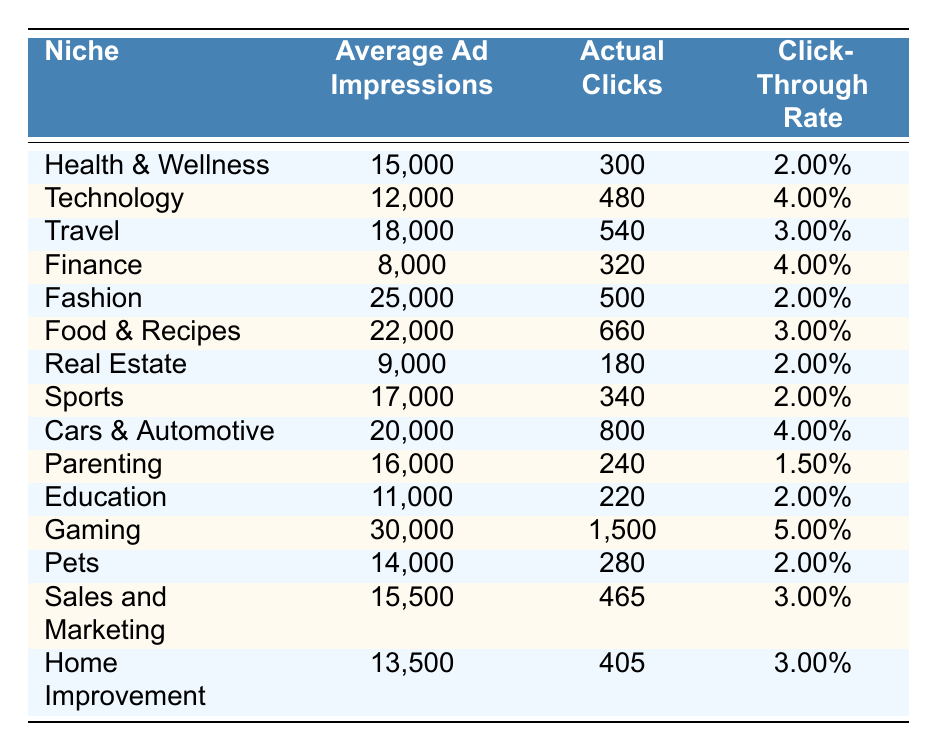What is the niche with the highest click-through rate? From the table, we identify that "Gaming" has the highest click-through rate of 5.00%.
Answer: Gaming How many actual clicks were recorded in the "Food & Recipes" niche? Referring to the table, "Food & Recipes" recorded 660 actual clicks.
Answer: 660 Which niche has the lowest average ad impressions? The "Finance" niche has the lowest average ad impressions with 8,000.
Answer: Finance What is the total number of actual clicks across all niches? We can sum up the actual clicks: 300 + 480 + 540 + 320 + 500 + 660 + 180 + 340 + 800 + 240 + 220 + 1500 + 280 + 465 + 405 = 5,125.
Answer: 5125 What is the average click-through rate for the niches listed? The total click-through rates are calculated as follows: (2 + 4 + 3 + 4 + 2 + 3 + 2 + 2 + 4 + 1.5 + 2 + 5 + 2 + 3 + 3)/15 = 2.67%, giving us the average.
Answer: 2.67% Is the click-through rate for "Parenting" greater than 2%? The table shows "Parenting" has a click-through rate of 1.50%, which is not greater than 2%.
Answer: No What is the difference between the average ad impressions of "Fashion" and "Cars & Automotive"? The average ad impressions for "Fashion" is 25,000 and for "Cars & Automotive" is 20,000. The difference is 25,000 - 20,000 = 5,000.
Answer: 5000 How many niches have a click-through rate higher than 3%? The niches "Technology", "Finance", "Cars & Automotive", and "Gaming" have a click-through rate higher than 3%, counting to a total of 4 niches.
Answer: 4 Which niches have both high average ad impressions and high actual clicks? Both "Gaming" with 30,000 ad impressions and 1500 clicks, and "Cars & Automotive" with 20,000 ad impressions and 800 clicks fit this criterion. Through visual analysis of the data, these niches stand out.
Answer: Gaming and Cars & Automotive What is the ratio of actual clicks to average ad impressions for the "Travel" niche? For the "Travel" niche, the actual clicks are 540 and average ad impressions are 18,000, thus the ratio is 540 / 18,000 = 0.03.
Answer: 0.03 Which niche has the second highest number of actual clicks? The niche "Food & Recipes" with 660 actual clicks is second to "Gaming" which has 1,500.
Answer: Food & Recipes 